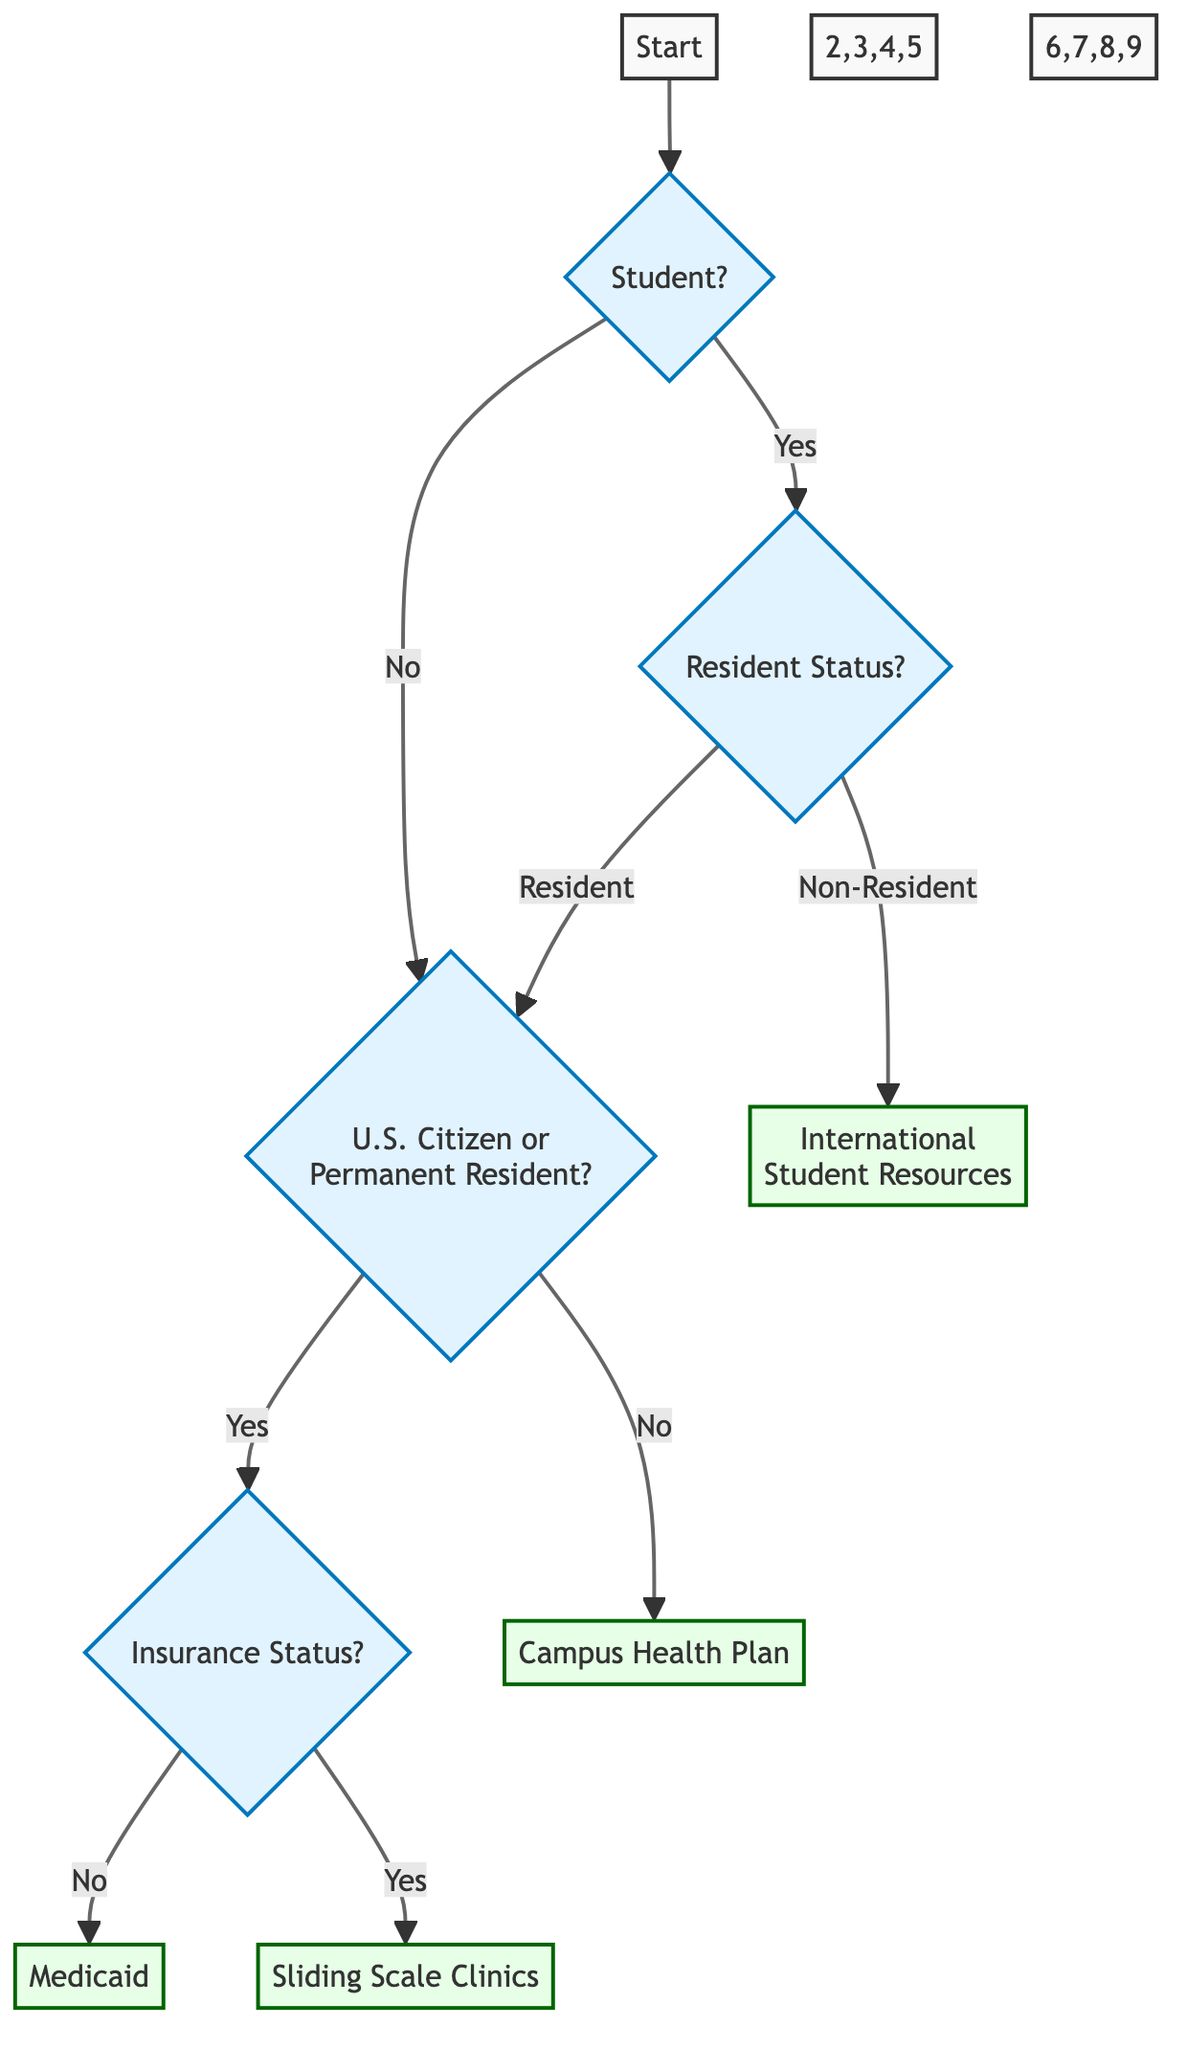What is the starting point of the decision tree? The starting point is the node labeled "Start," which indicates the initiation of the process for finding financial assistance programs.
Answer: Start How many decision nodes are in the diagram? The diagram contains five decision nodes: "Student," "Resident Status," "U.S. Citizen or Permanent Resident," "Insurance Status," and "Medicaid."
Answer: 5 What program is suggested for non-resident students? The program suggested for non-resident students is "International Student Resources." This is derived from the decision point where non-resident status is confirmed.
Answer: International Student Resources What is the next step if a student is a resident and a U.S. citizen? If a student is a resident and a U.S. citizen, the next step is to consider their health insurance status. This comes after confirming resident and citizenship status in the decision pathway.
Answer: Insurance Status What happens if a student has no health insurance? If a student has no health insurance, they are evaluated to see if they are eligible for Medicaid services. This follows the decision path established after confirming no health insurance.
Answer: Medicaid If a student has health insurance, which program do they consider? If a student has health insurance, they are directed to consider services from sliding scale clinics. This follows the insurance status check.
Answer: Sliding Scale Clinics What will a non-student examine for financial assistance? A non-student would examine the "U.S. Citizen or Permanent Resident" node for financial assistance options, which is the next logical step according to the decision tree's flow.
Answer: U.S. Citizen or Permanent Resident Is there a direct option for students without health insurance? Yes, students without health insurance have a direct option to pursue "Medicaid" for financial assistance. This follows the decision tree pathway when confirming no health insurance.
Answer: Medicaid 